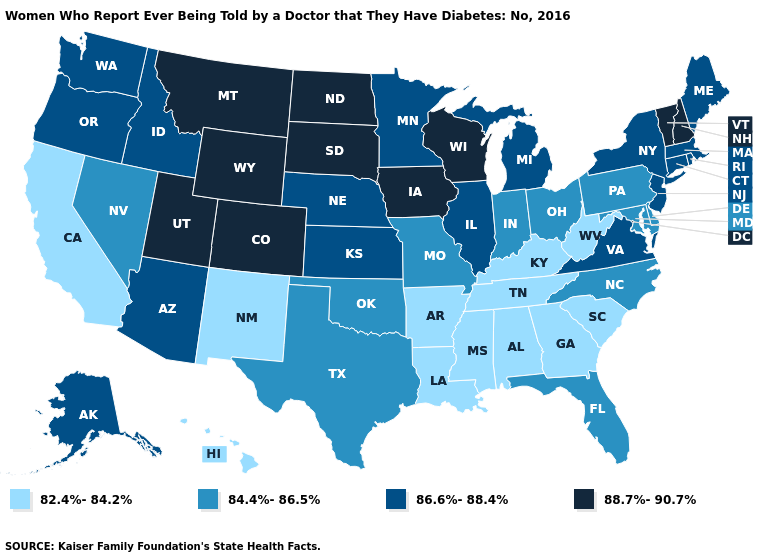What is the value of West Virginia?
Short answer required. 82.4%-84.2%. What is the value of Georgia?
Quick response, please. 82.4%-84.2%. What is the value of Louisiana?
Keep it brief. 82.4%-84.2%. What is the value of Indiana?
Quick response, please. 84.4%-86.5%. Name the states that have a value in the range 86.6%-88.4%?
Quick response, please. Alaska, Arizona, Connecticut, Idaho, Illinois, Kansas, Maine, Massachusetts, Michigan, Minnesota, Nebraska, New Jersey, New York, Oregon, Rhode Island, Virginia, Washington. What is the value of Georgia?
Short answer required. 82.4%-84.2%. Does Michigan have the lowest value in the MidWest?
Write a very short answer. No. Which states have the lowest value in the South?
Keep it brief. Alabama, Arkansas, Georgia, Kentucky, Louisiana, Mississippi, South Carolina, Tennessee, West Virginia. Name the states that have a value in the range 84.4%-86.5%?
Quick response, please. Delaware, Florida, Indiana, Maryland, Missouri, Nevada, North Carolina, Ohio, Oklahoma, Pennsylvania, Texas. Does the map have missing data?
Give a very brief answer. No. What is the highest value in states that border Illinois?
Short answer required. 88.7%-90.7%. Name the states that have a value in the range 86.6%-88.4%?
Write a very short answer. Alaska, Arizona, Connecticut, Idaho, Illinois, Kansas, Maine, Massachusetts, Michigan, Minnesota, Nebraska, New Jersey, New York, Oregon, Rhode Island, Virginia, Washington. How many symbols are there in the legend?
Answer briefly. 4. What is the value of Tennessee?
Answer briefly. 82.4%-84.2%. Is the legend a continuous bar?
Write a very short answer. No. 